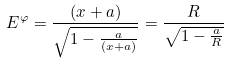Convert formula to latex. <formula><loc_0><loc_0><loc_500><loc_500>E ^ { \varphi } = \frac { ( x + a ) } { \sqrt { 1 - \frac { a } { ( x + a ) } } } = \frac { R } { \sqrt { 1 - \frac { a } { R } } }</formula> 